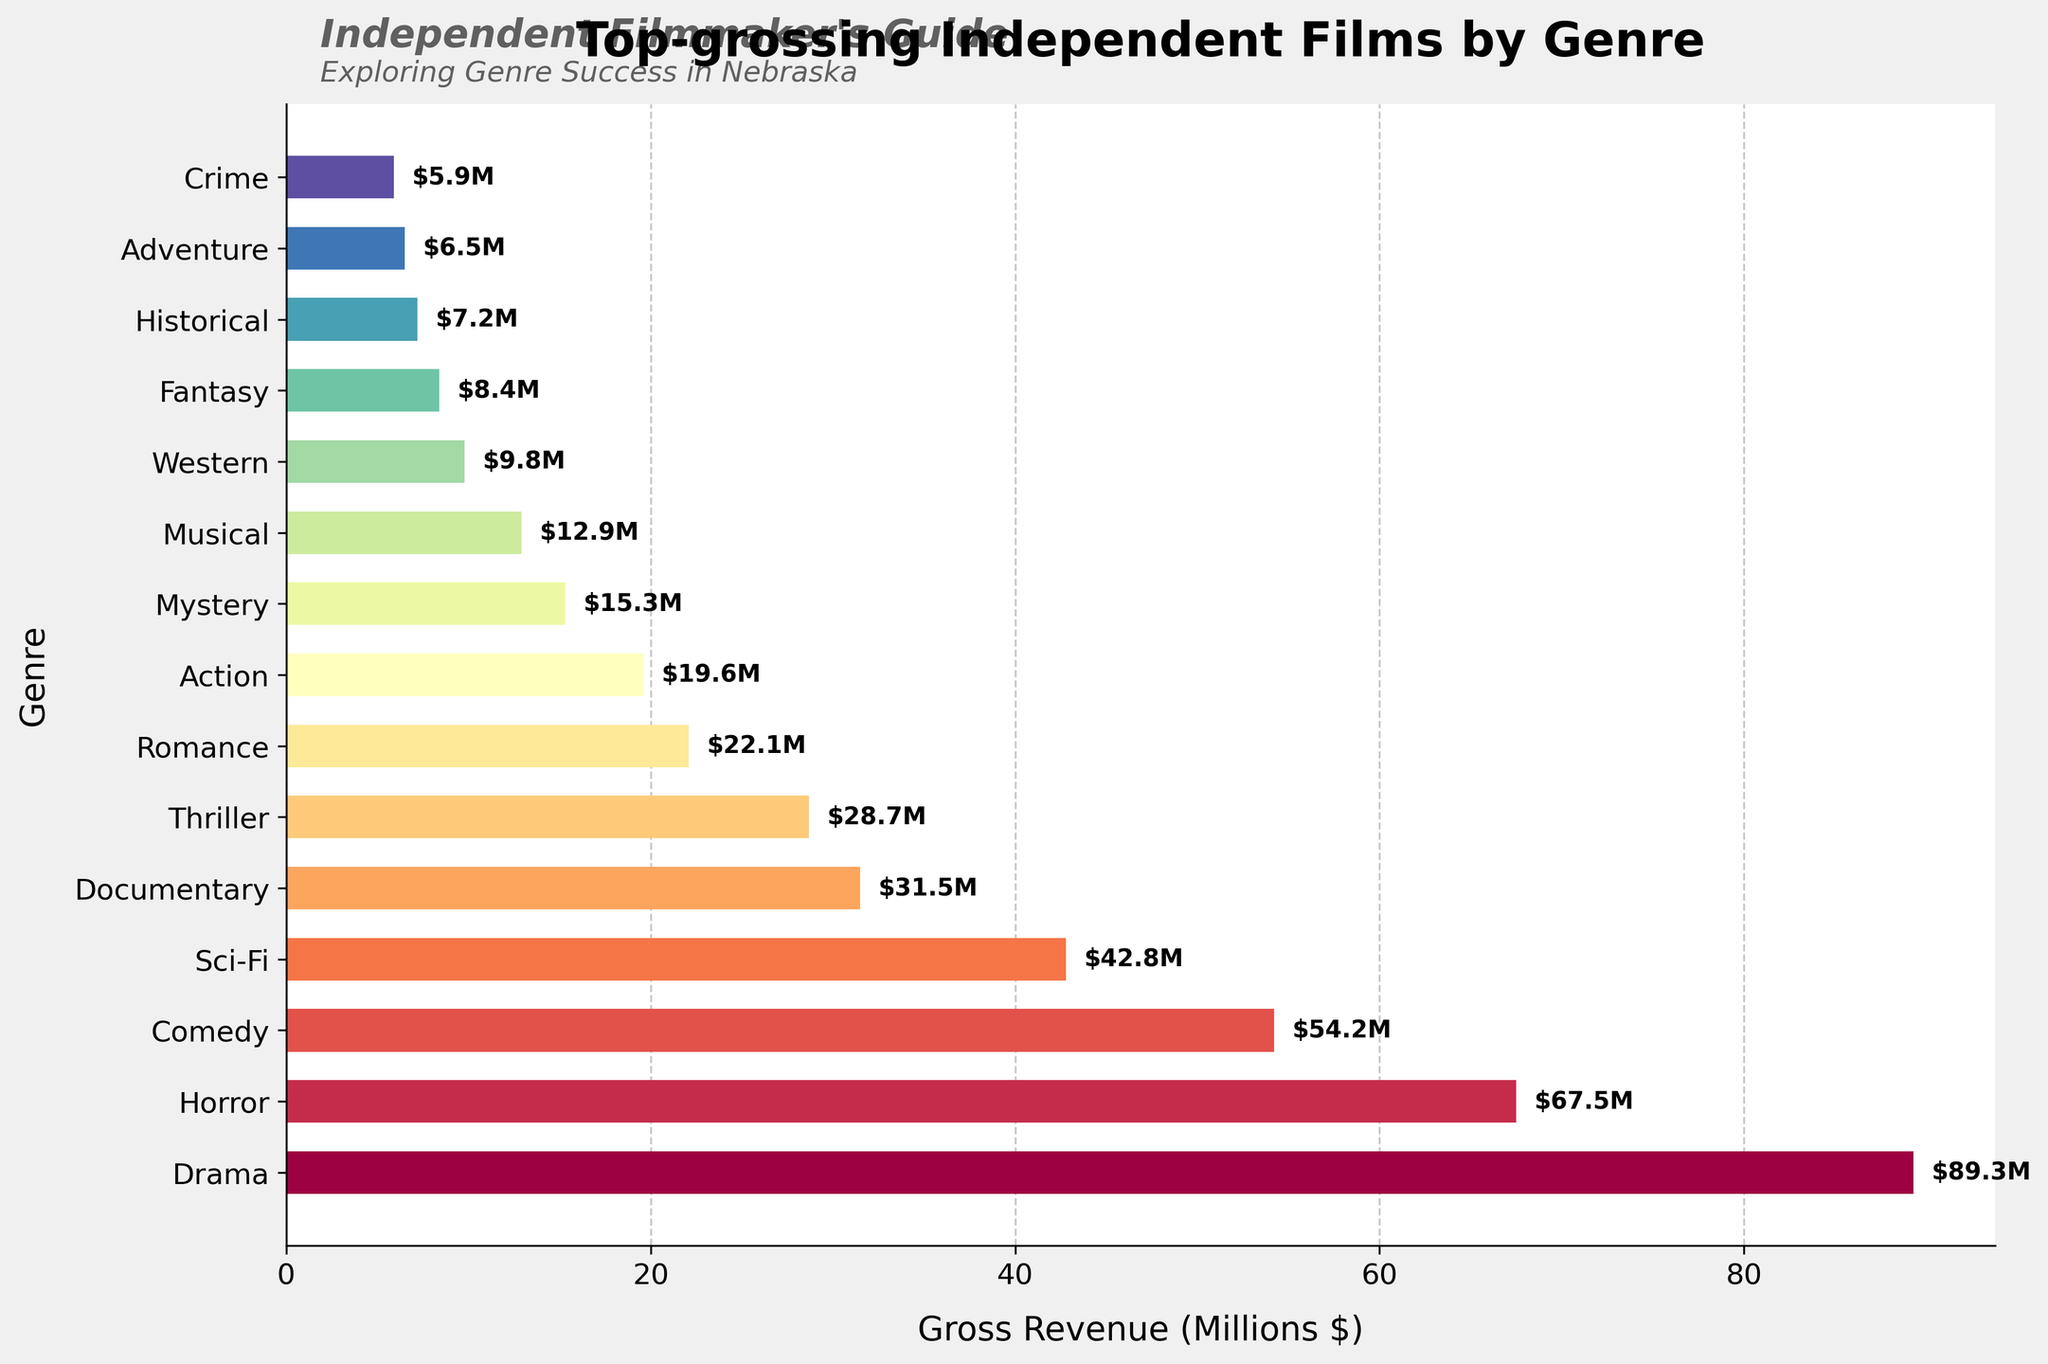Which genre has the highest gross revenue? The bar labeled "Drama" is the longest, showing it has the highest gross revenue.
Answer: Drama How much more did Drama gross compared to Horror? Drama grossed $89.3 million, while Horror grossed $67.5 million. The difference is $89.3M - $67.5M = $21.8M.
Answer: $21.8 million What is the combined gross revenue of Comedy, Sci-Fi, and Documentary? Add the revenues of Comedy ($54.2M), Sci-Fi ($42.8M), and Documentary ($31.5M). The total is $54.2M + $42.8M + $31.5M = $128.5M.
Answer: $128.5 million Which genre has the lowest gross revenue, and how much is it? The shortest bar represents the Western genre with a gross revenue of $5.9 million.
Answer: Crime, $5.9 million How does the gross revenue of Romance compare to that of Action? Romance grossed $22.1 million, and Action grossed $19.6 million. Romance's revenue is higher.
Answer: Romance > Action What are the total gross revenues for the top three genres combined? The top three genres are Drama ($89.3M), Horror ($67.5M), and Comedy ($54.2M). The total is $89.3M + $67.5M + $54.2M = $211M.
Answer: $211 million What is the gross revenue difference between Sci-Fi and Musical? Sci-Fi grossed $42.8 million, and Musical grossed $12.9 million. The difference is $42.8M - $12.9M = $29.9M.
Answer: $29.9 million Which genres grossed less than $10 million, and what are their revenues? Western ($9.8M), Fantasy ($8.4M), Historical ($7.2M), Adventure ($6.5M), and Crime ($5.9M) all grossed less than $10 million.
Answer: Western, Fantasy, Historical, Adventure, Crime Which genre is represented by the greenish bar and its gross revenue? The fifth bar from the top, colored greenish, represents Documentary with a gross revenue of $31.5 million.
Answer: Documentary, $31.5 million 